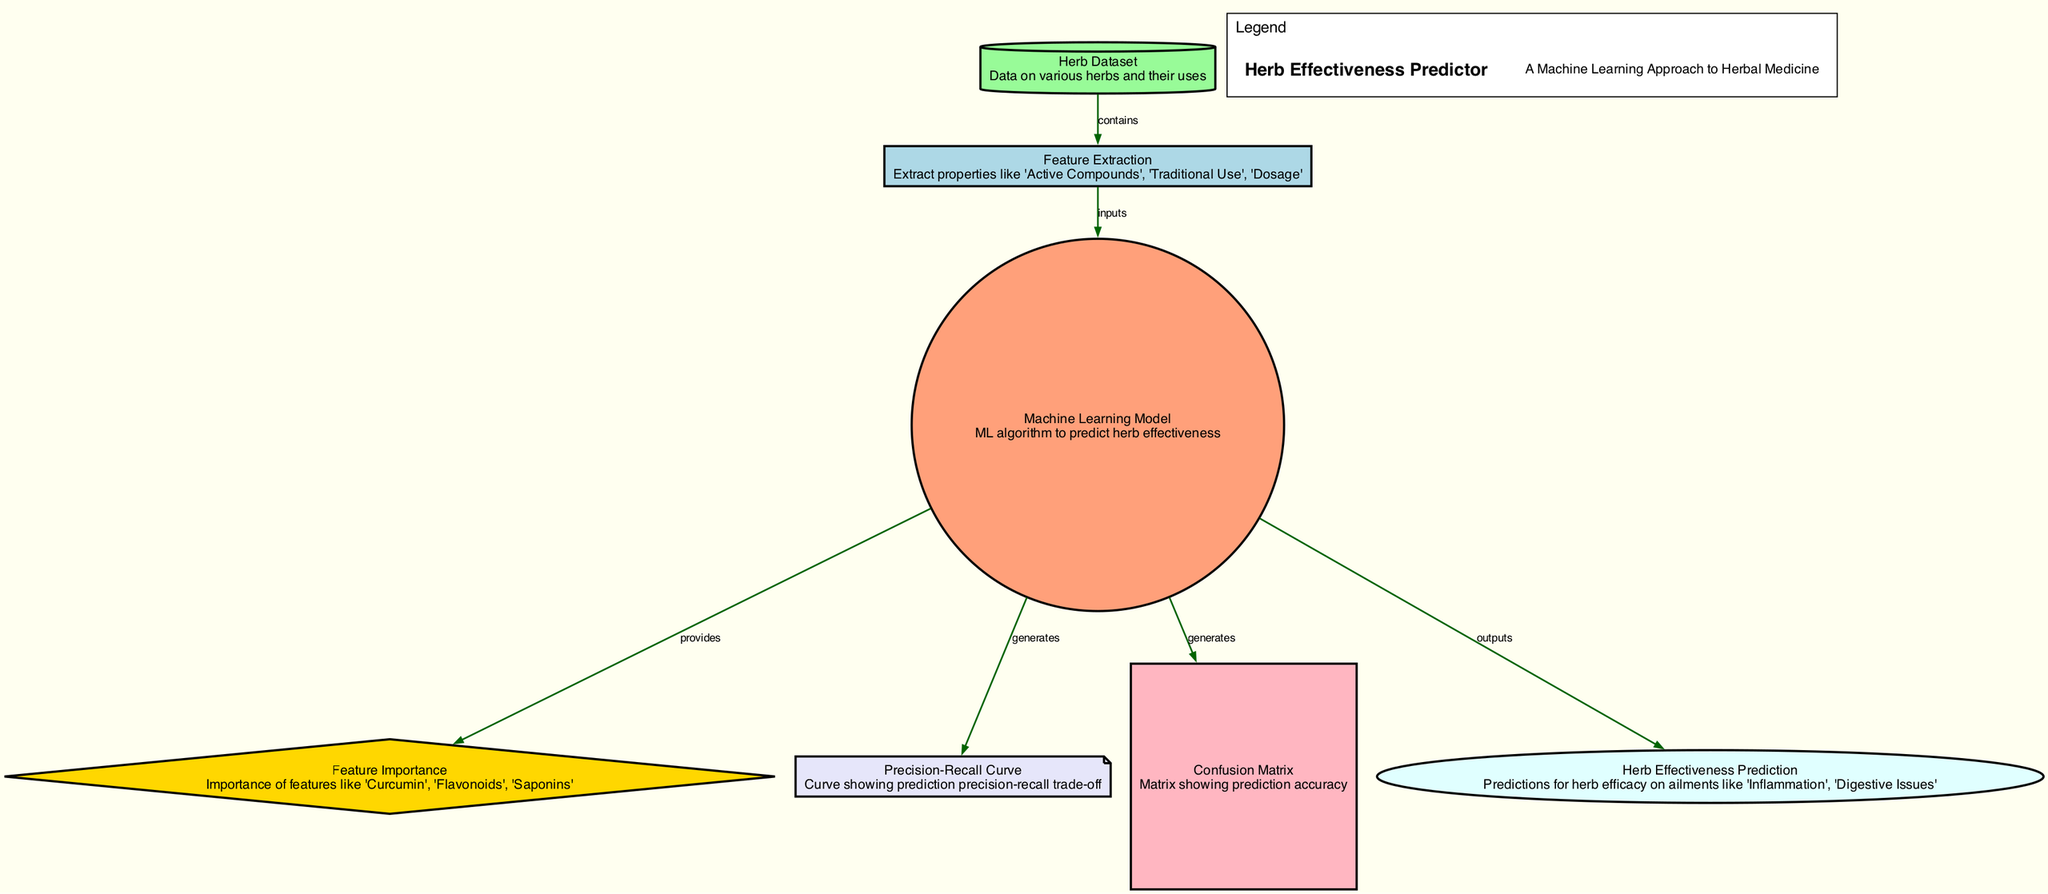What is the first node in the diagram? The first node in the diagram is labeled "Herb Dataset," indicating that this is where data on various herbs and their uses is stored.
Answer: Herb Dataset How many nodes are in the diagram? The diagram contains a total of seven nodes, each representing different stages or components in the herb effectiveness prediction process.
Answer: 7 What relationship exists between "Feature Extraction" and "Machine Learning Model"? The relationship is that "Feature Extraction" inputs data into the "Machine Learning Model," meaning that the extracted features are used as input for the model to make predictions.
Answer: inputs What does "Machine Learning Model" generate in the diagram? The "Machine Learning Model" generates both the "Precision-Recall Curve" and the "Confusion Matrix," which are used to evaluate the model's performance in terms of prediction accuracy and precision-recall trade-off.
Answer: Precision-Recall Curve, Confusion Matrix Which features are deemed most important according to the diagram? The diagram indicates that the important features include "Curcumin," "Flavonoids," and "Saponins," as highlighted under the "Feature Importance" node.
Answer: Curcumin, Flavonoids, Saponins How does "Herb Effectiveness Prediction" relate to the "Machine Learning Model"? "Herb Effectiveness Prediction" is the output of the "Machine Learning Model," meaning that it presents the predictions regarding the efficacy of various herbs in treating specific ailments based on the model's learned patterns.
Answer: outputs What is depicted in the "Confusion Matrix"? The "Confusion Matrix" depicts prediction accuracy, showing how well the model has performed in classifying herbs' effectiveness against actual outcomes compared to the predictions made.
Answer: prediction accuracy What kind of curve is represented in the diagram, and what does it illustrate? The diagram represents a "Precision-Recall Curve," which illustrates the trade-off between precision (true positive rate) and recall (sensitivity) in the predictions made by the machine learning model.
Answer: Precision-Recall Curve What type of data is included in the "Herb Dataset"? The "Herb Dataset" includes data on various herbs and their uses, serving as the foundational input for analysis and predictions concerning herb effectiveness.
Answer: data on various herbs and their uses 